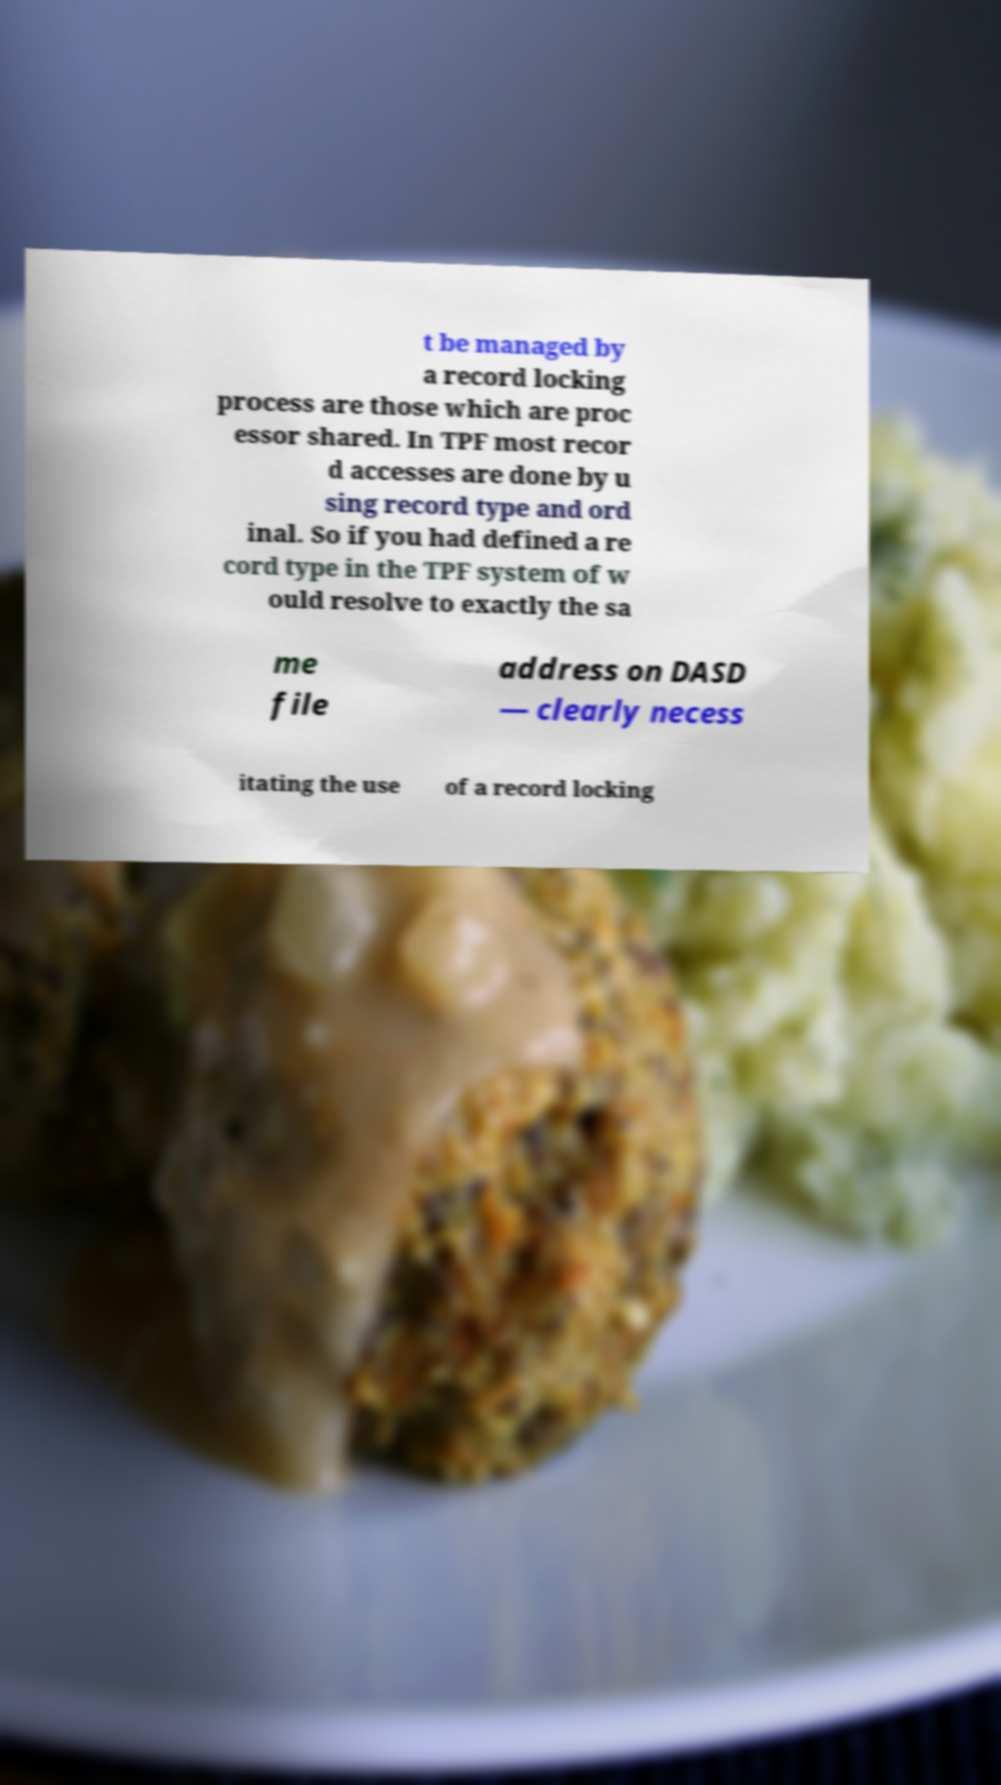There's text embedded in this image that I need extracted. Can you transcribe it verbatim? t be managed by a record locking process are those which are proc essor shared. In TPF most recor d accesses are done by u sing record type and ord inal. So if you had defined a re cord type in the TPF system of w ould resolve to exactly the sa me file address on DASD — clearly necess itating the use of a record locking 